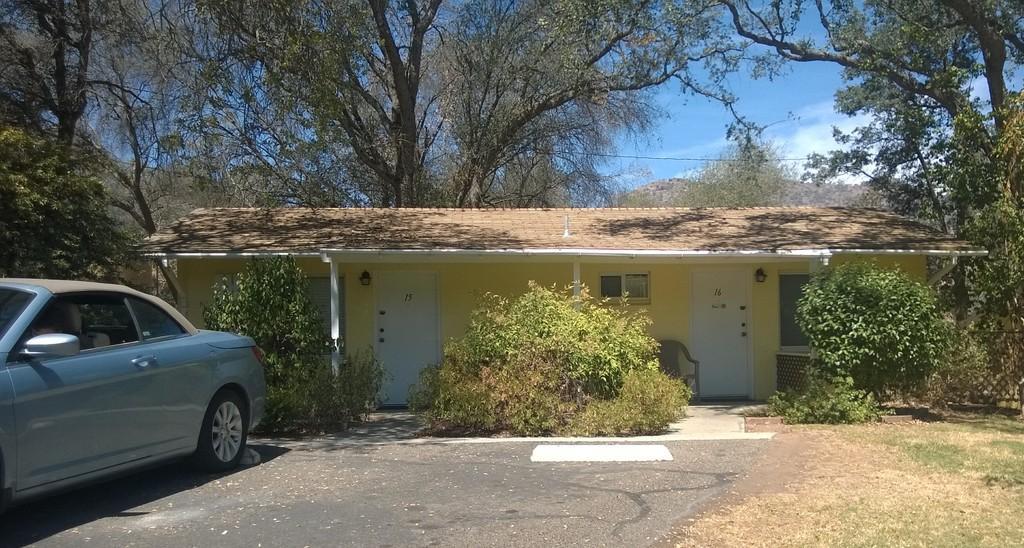Could you give a brief overview of what you see in this image? In this image I can see the plants and the house with doors and boards. I can see the chair. To the left I can see the vehicle. In the background I can see the clouds and the sky. 